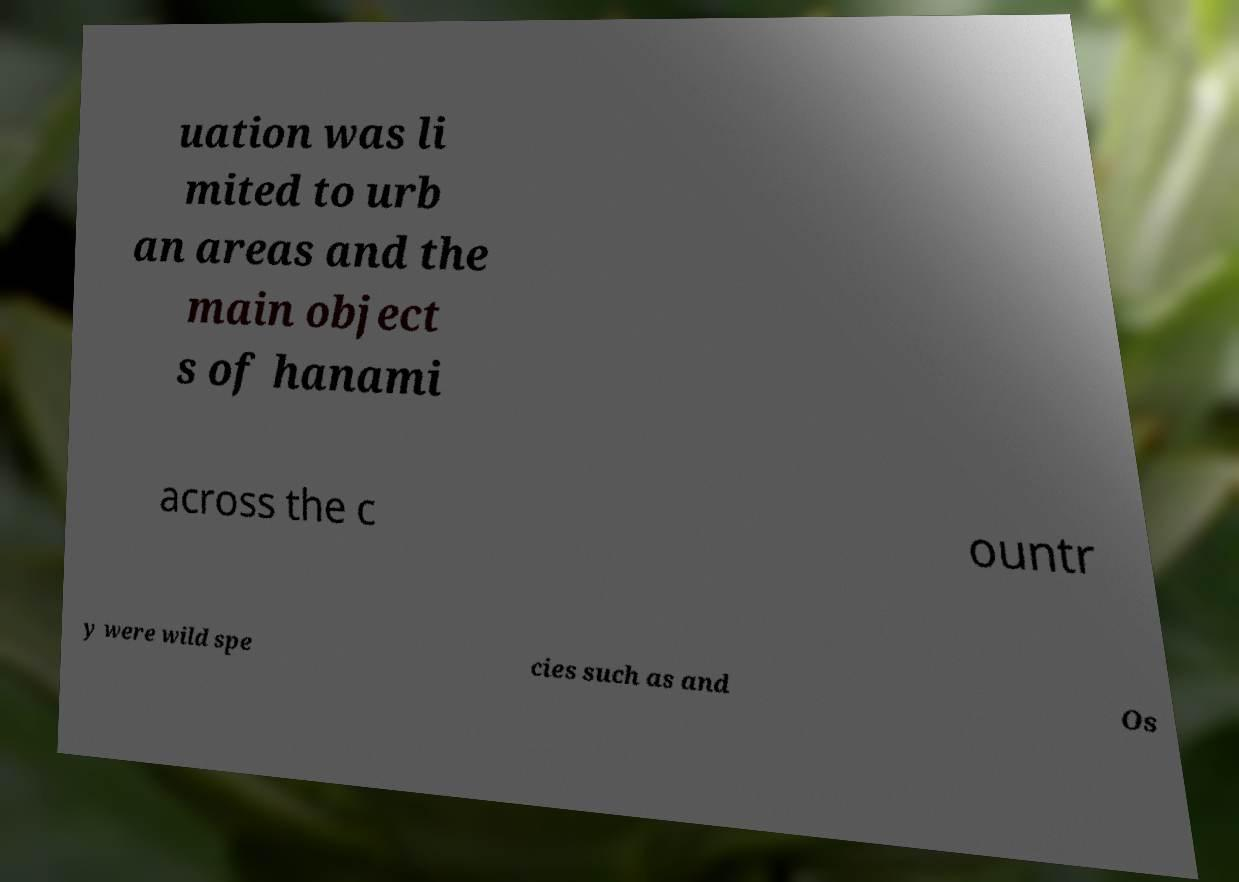Please read and relay the text visible in this image. What does it say? uation was li mited to urb an areas and the main object s of hanami across the c ountr y were wild spe cies such as and Os 